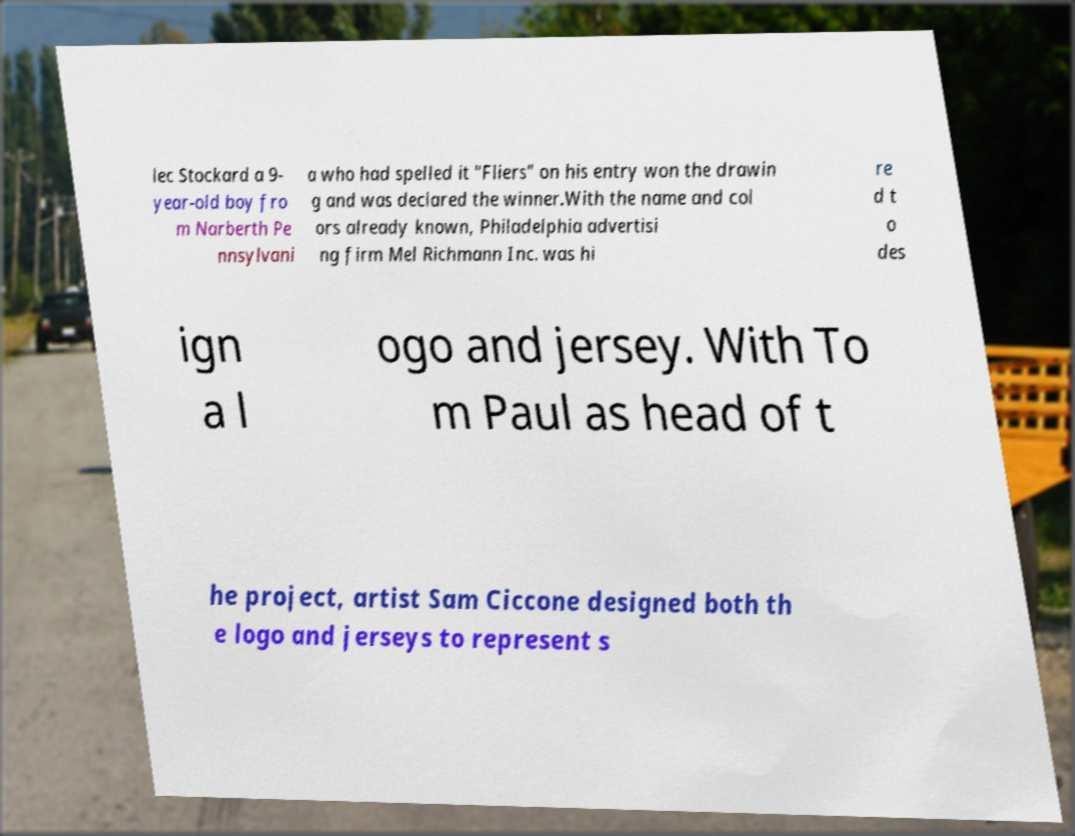There's text embedded in this image that I need extracted. Can you transcribe it verbatim? lec Stockard a 9- year-old boy fro m Narberth Pe nnsylvani a who had spelled it "Fliers" on his entry won the drawin g and was declared the winner.With the name and col ors already known, Philadelphia advertisi ng firm Mel Richmann Inc. was hi re d t o des ign a l ogo and jersey. With To m Paul as head of t he project, artist Sam Ciccone designed both th e logo and jerseys to represent s 